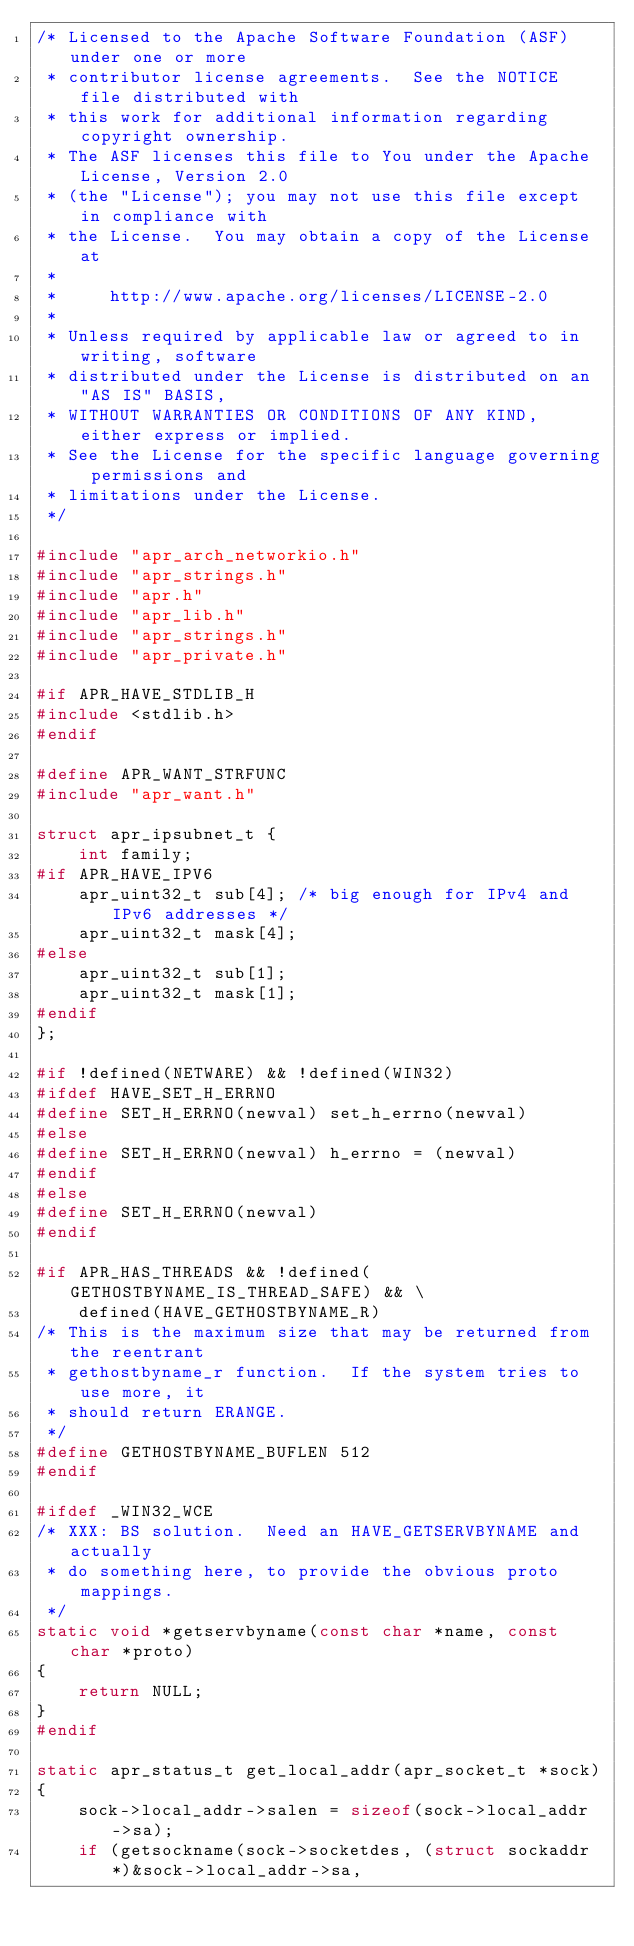Convert code to text. <code><loc_0><loc_0><loc_500><loc_500><_C_>/* Licensed to the Apache Software Foundation (ASF) under one or more
 * contributor license agreements.  See the NOTICE file distributed with
 * this work for additional information regarding copyright ownership.
 * The ASF licenses this file to You under the Apache License, Version 2.0
 * (the "License"); you may not use this file except in compliance with
 * the License.  You may obtain a copy of the License at
 *
 *     http://www.apache.org/licenses/LICENSE-2.0
 *
 * Unless required by applicable law or agreed to in writing, software
 * distributed under the License is distributed on an "AS IS" BASIS,
 * WITHOUT WARRANTIES OR CONDITIONS OF ANY KIND, either express or implied.
 * See the License for the specific language governing permissions and
 * limitations under the License.
 */

#include "apr_arch_networkio.h"
#include "apr_strings.h"
#include "apr.h"
#include "apr_lib.h"
#include "apr_strings.h"
#include "apr_private.h"

#if APR_HAVE_STDLIB_H
#include <stdlib.h>
#endif

#define APR_WANT_STRFUNC
#include "apr_want.h"

struct apr_ipsubnet_t {
    int family;
#if APR_HAVE_IPV6
    apr_uint32_t sub[4]; /* big enough for IPv4 and IPv6 addresses */
    apr_uint32_t mask[4];
#else
    apr_uint32_t sub[1];
    apr_uint32_t mask[1];
#endif
};

#if !defined(NETWARE) && !defined(WIN32)
#ifdef HAVE_SET_H_ERRNO
#define SET_H_ERRNO(newval) set_h_errno(newval)
#else
#define SET_H_ERRNO(newval) h_errno = (newval)
#endif
#else
#define SET_H_ERRNO(newval)
#endif

#if APR_HAS_THREADS && !defined(GETHOSTBYNAME_IS_THREAD_SAFE) && \
    defined(HAVE_GETHOSTBYNAME_R)
/* This is the maximum size that may be returned from the reentrant
 * gethostbyname_r function.  If the system tries to use more, it
 * should return ERANGE.
 */
#define GETHOSTBYNAME_BUFLEN 512
#endif

#ifdef _WIN32_WCE
/* XXX: BS solution.  Need an HAVE_GETSERVBYNAME and actually
 * do something here, to provide the obvious proto mappings.
 */
static void *getservbyname(const char *name, const char *proto)
{
    return NULL;
}
#endif

static apr_status_t get_local_addr(apr_socket_t *sock)
{
    sock->local_addr->salen = sizeof(sock->local_addr->sa);
    if (getsockname(sock->socketdes, (struct sockaddr *)&sock->local_addr->sa,</code> 